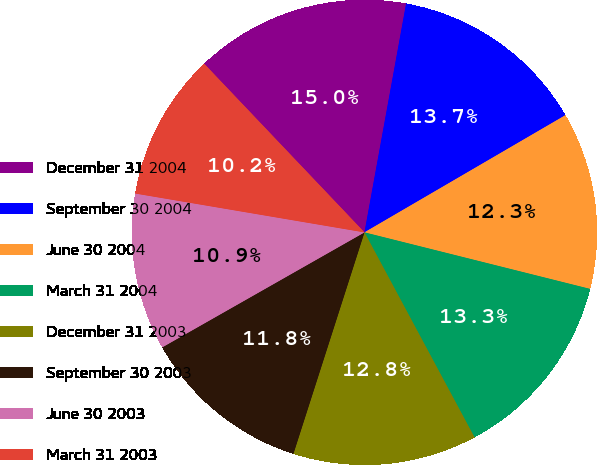Convert chart. <chart><loc_0><loc_0><loc_500><loc_500><pie_chart><fcel>December 31 2004<fcel>September 30 2004<fcel>June 30 2004<fcel>March 31 2004<fcel>December 31 2003<fcel>September 30 2003<fcel>June 30 2003<fcel>March 31 2003<nl><fcel>14.96%<fcel>13.73%<fcel>12.31%<fcel>13.25%<fcel>12.78%<fcel>11.83%<fcel>10.9%<fcel>10.23%<nl></chart> 